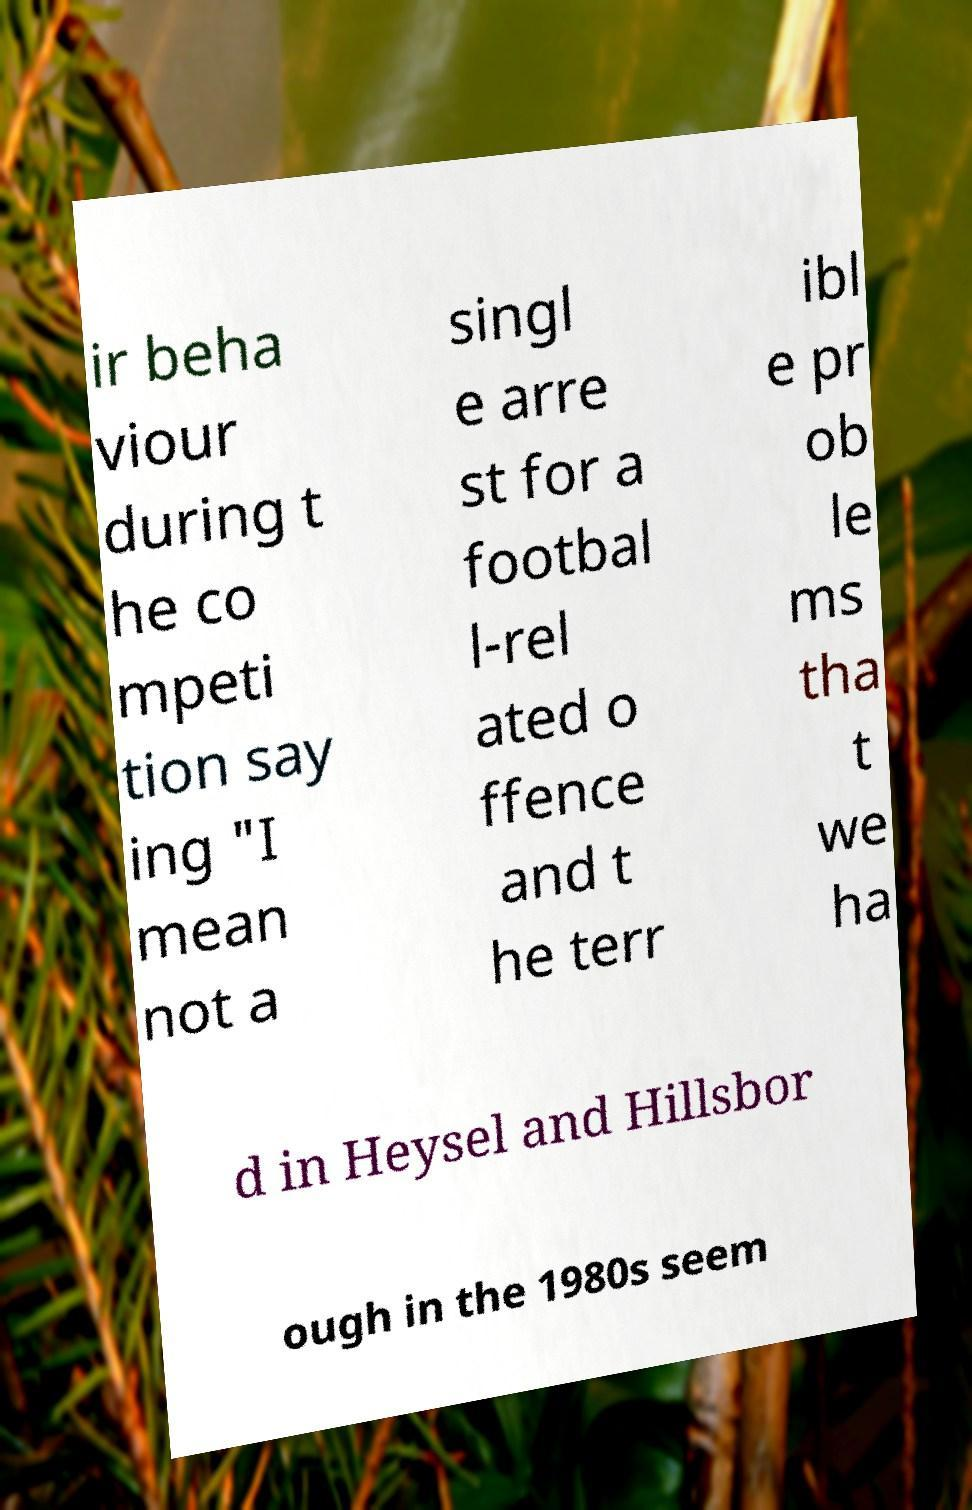For documentation purposes, I need the text within this image transcribed. Could you provide that? ir beha viour during t he co mpeti tion say ing "I mean not a singl e arre st for a footbal l-rel ated o ffence and t he terr ibl e pr ob le ms tha t we ha d in Heysel and Hillsbor ough in the 1980s seem 